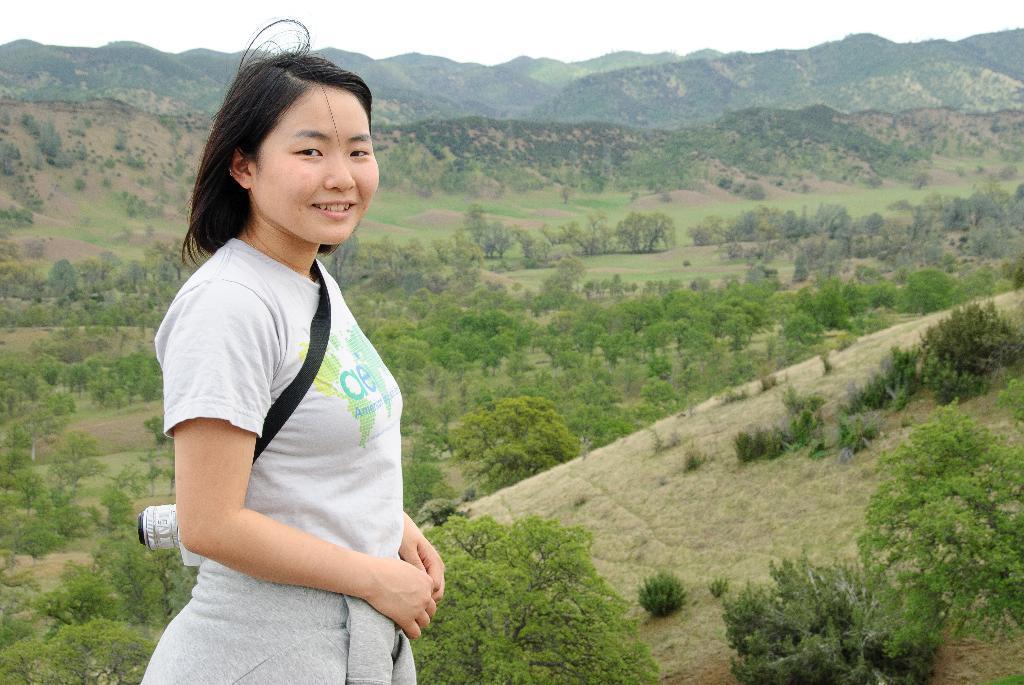Please provide a concise description of this image. In this picture there is a woman towards the left. She is wearing a grey top and grey jacket and she is carrying a camera. In the background there are hills with trees. 